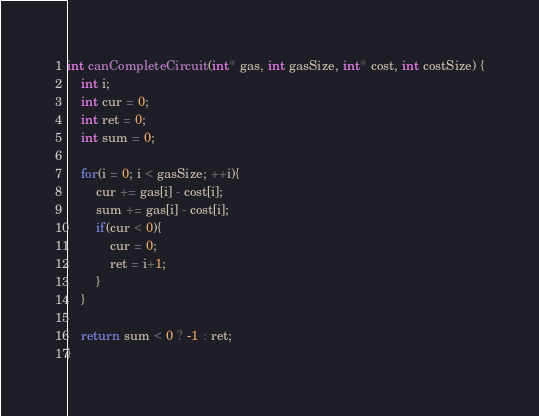<code> <loc_0><loc_0><loc_500><loc_500><_C_>int canCompleteCircuit(int* gas, int gasSize, int* cost, int costSize) {
    int i;
    int cur = 0;
    int ret = 0;
    int sum = 0;

    for(i = 0; i < gasSize; ++i){
        cur += gas[i] - cost[i];
        sum += gas[i] - cost[i];
        if(cur < 0){
            cur = 0;
            ret = i+1;
        }
    }

    return sum < 0 ? -1 : ret;
}
</code> 